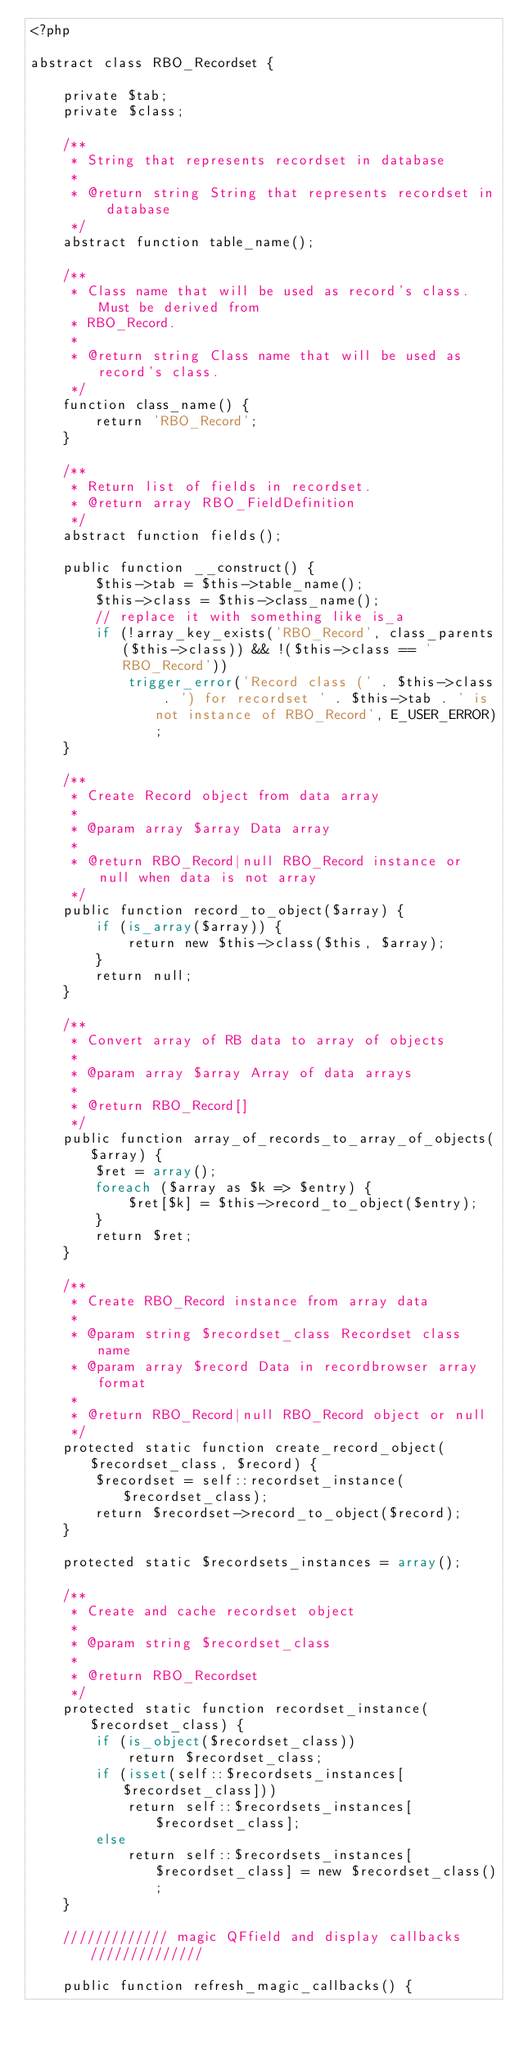<code> <loc_0><loc_0><loc_500><loc_500><_PHP_><?php

abstract class RBO_Recordset {

    private $tab;
    private $class;

    /**
     * String that represents recordset in database
     *
     * @return string String that represents recordset in database
     */
    abstract function table_name();

    /**
     * Class name that will be used as record's class. Must be derived from
     * RBO_Record.
     *
     * @return string Class name that will be used as record's class.
     */
    function class_name() {
        return 'RBO_Record';
    }

    /**
     * Return list of fields in recordset.
     * @return array RBO_FieldDefinition
     */
    abstract function fields();

    public function __construct() {
        $this->tab = $this->table_name();
        $this->class = $this->class_name();
        // replace it with something like is_a
        if (!array_key_exists('RBO_Record', class_parents($this->class)) && !($this->class == 'RBO_Record'))
            trigger_error('Record class (' . $this->class . ') for recordset ' . $this->tab . ' is not instance of RBO_Record', E_USER_ERROR);
    }

    /**
     * Create Record object from data array
     *
     * @param array $array Data array
     *
     * @return RBO_Record|null RBO_Record instance or null when data is not array
     */
    public function record_to_object($array) {
        if (is_array($array)) {
            return new $this->class($this, $array);
        }
        return null;
    }

    /**
     * Convert array of RB data to array of objects
     *
     * @param array $array Array of data arrays
     *
     * @return RBO_Record[]
     */
    public function array_of_records_to_array_of_objects($array) {
        $ret = array();
        foreach ($array as $k => $entry) {
            $ret[$k] = $this->record_to_object($entry);
        }
        return $ret;
    }

    /**
     * Create RBO_Record instance from array data
     *
     * @param string $recordset_class Recordset class name
     * @param array $record Data in recordbrowser array format
     *
     * @return RBO_Record|null RBO_Record object or null
     */
    protected static function create_record_object($recordset_class, $record) {
        $recordset = self::recordset_instance($recordset_class);
        return $recordset->record_to_object($record);
    }

    protected static $recordsets_instances = array();

    /**
     * Create and cache recordset object
     *
     * @param string $recordset_class
     *
     * @return RBO_Recordset
     */
    protected static function recordset_instance($recordset_class) {
        if (is_object($recordset_class))
            return $recordset_class;
        if (isset(self::$recordsets_instances[$recordset_class]))
            return self::$recordsets_instances[$recordset_class];
        else
            return self::$recordsets_instances[$recordset_class] = new $recordset_class();
    }

    ///////////// magic QFfield and display callbacks //////////////

    public function refresh_magic_callbacks() {</code> 